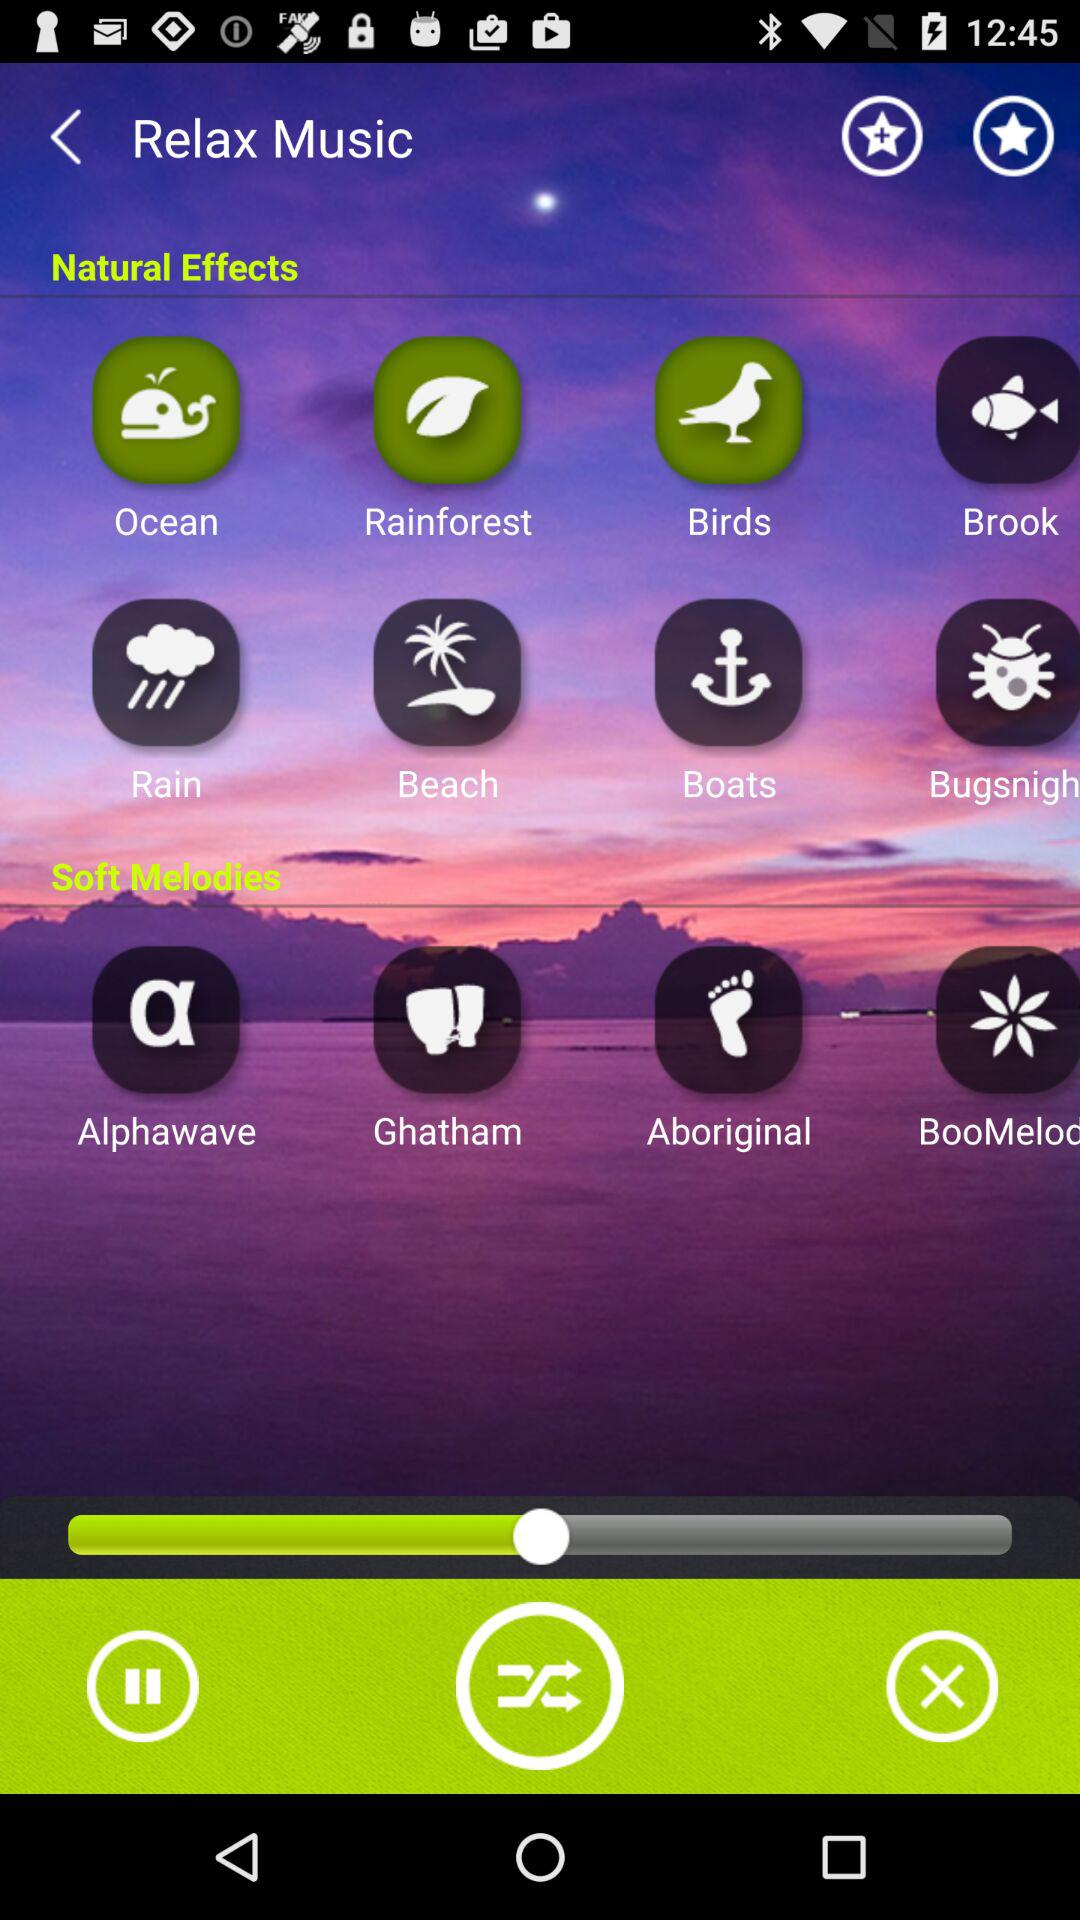What are the different options available in "Natural Effects"? The different available options are "Ocean", "Rainforest", "Birds", "Brook", "Rain", "Beach" and "Boats". 